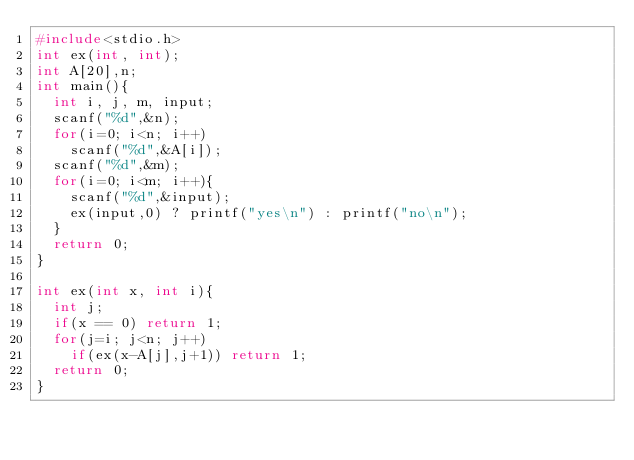Convert code to text. <code><loc_0><loc_0><loc_500><loc_500><_C_>#include<stdio.h>
int ex(int, int);
int A[20],n;
int main(){
  int i, j, m, input;
  scanf("%d",&n);
  for(i=0; i<n; i++)
    scanf("%d",&A[i]);
  scanf("%d",&m);
  for(i=0; i<m; i++){
    scanf("%d",&input);
    ex(input,0) ? printf("yes\n") : printf("no\n");
  }
  return 0;
}

int ex(int x, int i){
  int j;
  if(x == 0) return 1;
  for(j=i; j<n; j++)
    if(ex(x-A[j],j+1)) return 1;
  return 0;
}</code> 